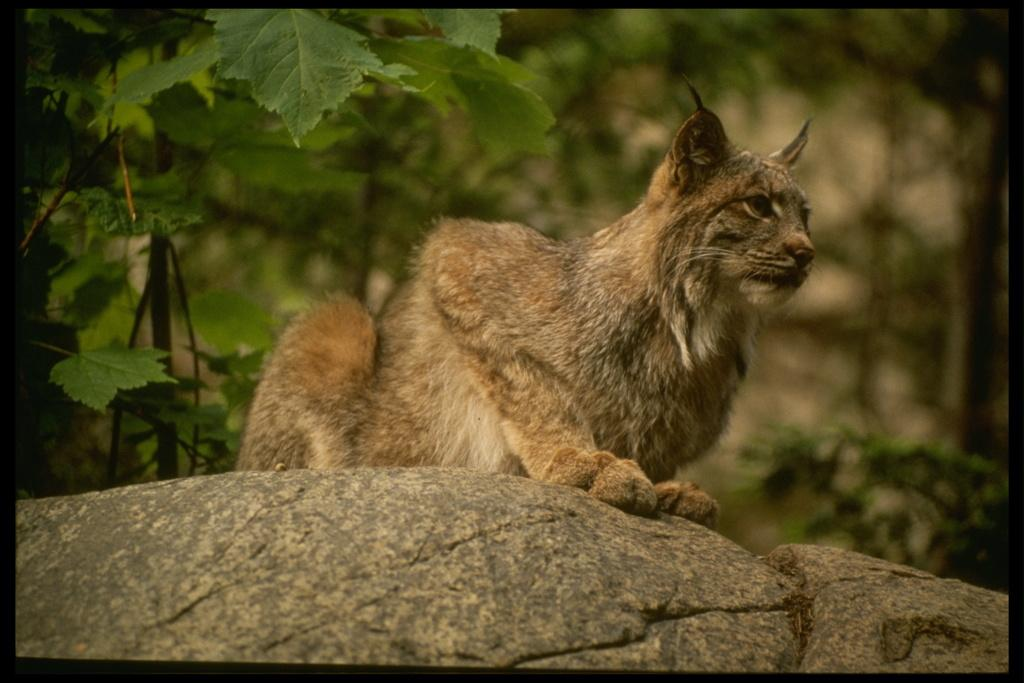What is the main subject of the image? There is an animal on a rock in the image. What can be seen in the background of the image? There are trees and plants in the background of the image. What feature does the image have? The image has borders. What type of cart is being used by the fireman in the image? There is no cart or fireman present in the image; it features an animal on a rock with trees in the background. 